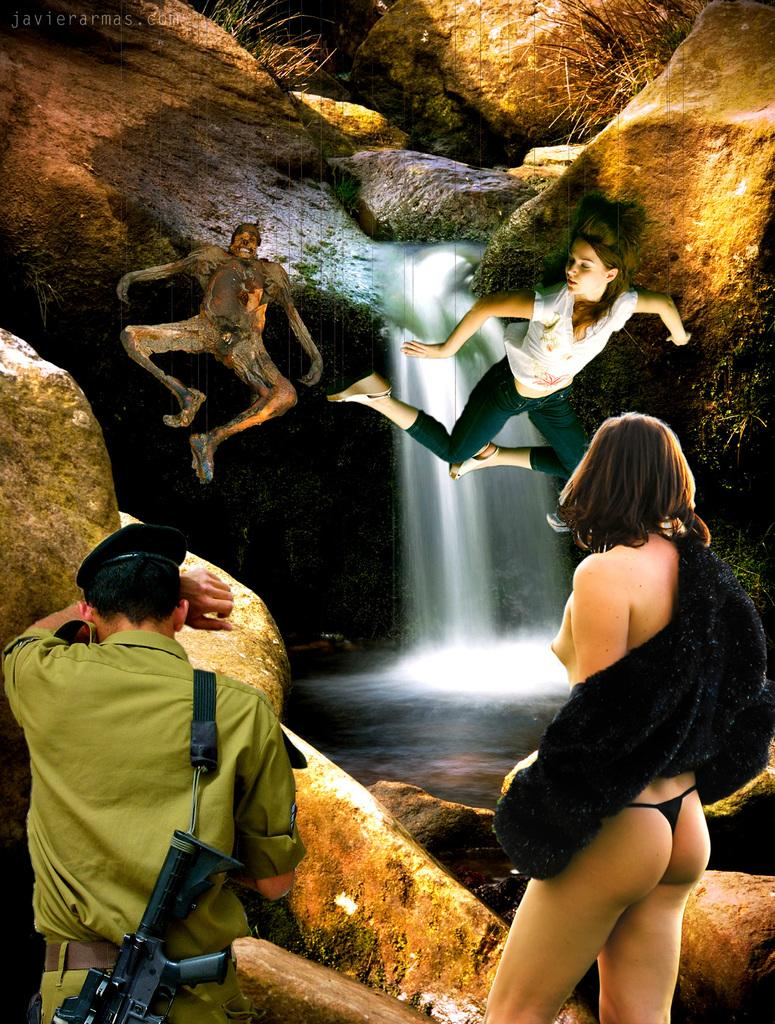What type of image is being described? The image is graphical. Who or what can be seen in the image? There are people in the image. What natural elements are present in the image? There are rocks and grass in the image. What type of lettuce is being served to the goldfish in the image? There is no lettuce or goldfish present in the image. 